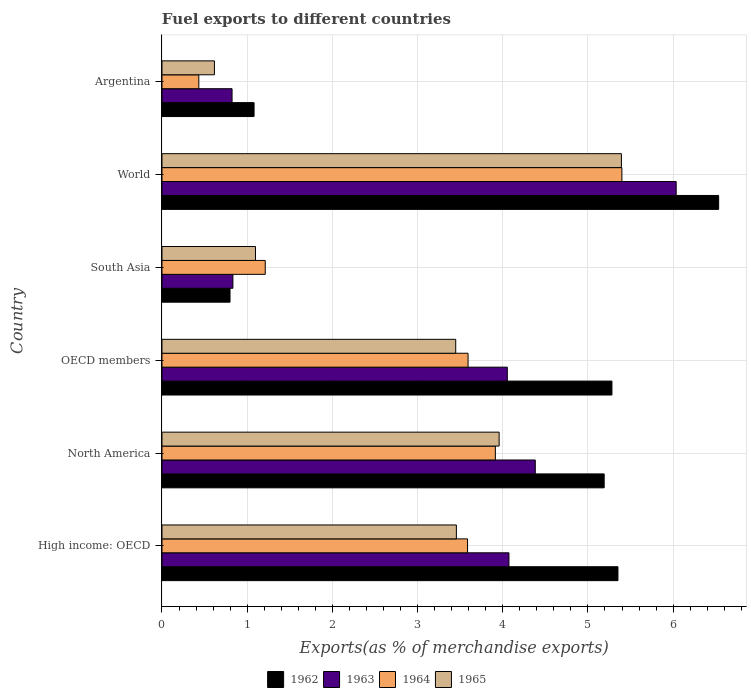How many different coloured bars are there?
Keep it short and to the point. 4. Are the number of bars on each tick of the Y-axis equal?
Ensure brevity in your answer.  Yes. In how many cases, is the number of bars for a given country not equal to the number of legend labels?
Your answer should be compact. 0. What is the percentage of exports to different countries in 1965 in Argentina?
Your answer should be very brief. 0.62. Across all countries, what is the maximum percentage of exports to different countries in 1962?
Offer a terse response. 6.53. Across all countries, what is the minimum percentage of exports to different countries in 1963?
Your answer should be compact. 0.82. In which country was the percentage of exports to different countries in 1963 minimum?
Provide a short and direct response. Argentina. What is the total percentage of exports to different countries in 1965 in the graph?
Give a very brief answer. 17.97. What is the difference between the percentage of exports to different countries in 1962 in OECD members and that in World?
Provide a succinct answer. -1.25. What is the difference between the percentage of exports to different countries in 1963 in North America and the percentage of exports to different countries in 1962 in High income: OECD?
Keep it short and to the point. -0.97. What is the average percentage of exports to different countries in 1962 per country?
Keep it short and to the point. 4.04. What is the difference between the percentage of exports to different countries in 1962 and percentage of exports to different countries in 1963 in North America?
Offer a terse response. 0.81. What is the ratio of the percentage of exports to different countries in 1964 in High income: OECD to that in North America?
Your answer should be very brief. 0.92. Is the difference between the percentage of exports to different countries in 1962 in OECD members and World greater than the difference between the percentage of exports to different countries in 1963 in OECD members and World?
Make the answer very short. Yes. What is the difference between the highest and the second highest percentage of exports to different countries in 1964?
Your answer should be very brief. 1.49. What is the difference between the highest and the lowest percentage of exports to different countries in 1965?
Your answer should be compact. 4.78. What does the 2nd bar from the top in OECD members represents?
Your response must be concise. 1964. How many bars are there?
Offer a very short reply. 24. Does the graph contain any zero values?
Provide a succinct answer. No. Does the graph contain grids?
Keep it short and to the point. Yes. Where does the legend appear in the graph?
Your response must be concise. Bottom center. How many legend labels are there?
Give a very brief answer. 4. What is the title of the graph?
Keep it short and to the point. Fuel exports to different countries. Does "2004" appear as one of the legend labels in the graph?
Provide a succinct answer. No. What is the label or title of the X-axis?
Provide a short and direct response. Exports(as % of merchandise exports). What is the label or title of the Y-axis?
Provide a succinct answer. Country. What is the Exports(as % of merchandise exports) in 1962 in High income: OECD?
Make the answer very short. 5.35. What is the Exports(as % of merchandise exports) in 1963 in High income: OECD?
Offer a terse response. 4.07. What is the Exports(as % of merchandise exports) of 1964 in High income: OECD?
Offer a very short reply. 3.59. What is the Exports(as % of merchandise exports) in 1965 in High income: OECD?
Your answer should be very brief. 3.46. What is the Exports(as % of merchandise exports) of 1962 in North America?
Keep it short and to the point. 5.19. What is the Exports(as % of merchandise exports) in 1963 in North America?
Offer a very short reply. 4.38. What is the Exports(as % of merchandise exports) in 1964 in North America?
Your answer should be compact. 3.91. What is the Exports(as % of merchandise exports) in 1965 in North America?
Offer a very short reply. 3.96. What is the Exports(as % of merchandise exports) in 1962 in OECD members?
Keep it short and to the point. 5.28. What is the Exports(as % of merchandise exports) in 1963 in OECD members?
Your answer should be very brief. 4.05. What is the Exports(as % of merchandise exports) in 1964 in OECD members?
Offer a very short reply. 3.59. What is the Exports(as % of merchandise exports) of 1965 in OECD members?
Make the answer very short. 3.45. What is the Exports(as % of merchandise exports) of 1962 in South Asia?
Make the answer very short. 0.8. What is the Exports(as % of merchandise exports) in 1963 in South Asia?
Give a very brief answer. 0.83. What is the Exports(as % of merchandise exports) in 1964 in South Asia?
Offer a very short reply. 1.21. What is the Exports(as % of merchandise exports) in 1965 in South Asia?
Ensure brevity in your answer.  1.1. What is the Exports(as % of merchandise exports) in 1962 in World?
Your response must be concise. 6.53. What is the Exports(as % of merchandise exports) of 1963 in World?
Offer a terse response. 6.04. What is the Exports(as % of merchandise exports) in 1964 in World?
Keep it short and to the point. 5.4. What is the Exports(as % of merchandise exports) in 1965 in World?
Make the answer very short. 5.39. What is the Exports(as % of merchandise exports) in 1962 in Argentina?
Keep it short and to the point. 1.08. What is the Exports(as % of merchandise exports) in 1963 in Argentina?
Your answer should be very brief. 0.82. What is the Exports(as % of merchandise exports) of 1964 in Argentina?
Your response must be concise. 0.43. What is the Exports(as % of merchandise exports) of 1965 in Argentina?
Your response must be concise. 0.62. Across all countries, what is the maximum Exports(as % of merchandise exports) in 1962?
Offer a terse response. 6.53. Across all countries, what is the maximum Exports(as % of merchandise exports) of 1963?
Provide a succinct answer. 6.04. Across all countries, what is the maximum Exports(as % of merchandise exports) in 1964?
Keep it short and to the point. 5.4. Across all countries, what is the maximum Exports(as % of merchandise exports) in 1965?
Give a very brief answer. 5.39. Across all countries, what is the minimum Exports(as % of merchandise exports) of 1962?
Ensure brevity in your answer.  0.8. Across all countries, what is the minimum Exports(as % of merchandise exports) of 1963?
Make the answer very short. 0.82. Across all countries, what is the minimum Exports(as % of merchandise exports) in 1964?
Your response must be concise. 0.43. Across all countries, what is the minimum Exports(as % of merchandise exports) of 1965?
Your response must be concise. 0.62. What is the total Exports(as % of merchandise exports) in 1962 in the graph?
Ensure brevity in your answer.  24.24. What is the total Exports(as % of merchandise exports) of 1963 in the graph?
Your response must be concise. 20.2. What is the total Exports(as % of merchandise exports) of 1964 in the graph?
Make the answer very short. 18.14. What is the total Exports(as % of merchandise exports) in 1965 in the graph?
Offer a very short reply. 17.97. What is the difference between the Exports(as % of merchandise exports) of 1962 in High income: OECD and that in North America?
Provide a short and direct response. 0.16. What is the difference between the Exports(as % of merchandise exports) in 1963 in High income: OECD and that in North America?
Offer a terse response. -0.31. What is the difference between the Exports(as % of merchandise exports) of 1964 in High income: OECD and that in North America?
Your answer should be very brief. -0.33. What is the difference between the Exports(as % of merchandise exports) of 1965 in High income: OECD and that in North America?
Your response must be concise. -0.5. What is the difference between the Exports(as % of merchandise exports) in 1962 in High income: OECD and that in OECD members?
Offer a terse response. 0.07. What is the difference between the Exports(as % of merchandise exports) of 1963 in High income: OECD and that in OECD members?
Provide a succinct answer. 0.02. What is the difference between the Exports(as % of merchandise exports) in 1964 in High income: OECD and that in OECD members?
Keep it short and to the point. -0.01. What is the difference between the Exports(as % of merchandise exports) in 1965 in High income: OECD and that in OECD members?
Make the answer very short. 0.01. What is the difference between the Exports(as % of merchandise exports) in 1962 in High income: OECD and that in South Asia?
Your answer should be compact. 4.55. What is the difference between the Exports(as % of merchandise exports) of 1963 in High income: OECD and that in South Asia?
Your response must be concise. 3.24. What is the difference between the Exports(as % of merchandise exports) in 1964 in High income: OECD and that in South Asia?
Ensure brevity in your answer.  2.37. What is the difference between the Exports(as % of merchandise exports) in 1965 in High income: OECD and that in South Asia?
Offer a terse response. 2.36. What is the difference between the Exports(as % of merchandise exports) in 1962 in High income: OECD and that in World?
Give a very brief answer. -1.18. What is the difference between the Exports(as % of merchandise exports) in 1963 in High income: OECD and that in World?
Your answer should be compact. -1.96. What is the difference between the Exports(as % of merchandise exports) of 1964 in High income: OECD and that in World?
Your response must be concise. -1.81. What is the difference between the Exports(as % of merchandise exports) in 1965 in High income: OECD and that in World?
Give a very brief answer. -1.94. What is the difference between the Exports(as % of merchandise exports) in 1962 in High income: OECD and that in Argentina?
Provide a short and direct response. 4.27. What is the difference between the Exports(as % of merchandise exports) of 1963 in High income: OECD and that in Argentina?
Make the answer very short. 3.25. What is the difference between the Exports(as % of merchandise exports) of 1964 in High income: OECD and that in Argentina?
Provide a succinct answer. 3.15. What is the difference between the Exports(as % of merchandise exports) in 1965 in High income: OECD and that in Argentina?
Give a very brief answer. 2.84. What is the difference between the Exports(as % of merchandise exports) of 1962 in North America and that in OECD members?
Make the answer very short. -0.09. What is the difference between the Exports(as % of merchandise exports) in 1963 in North America and that in OECD members?
Make the answer very short. 0.33. What is the difference between the Exports(as % of merchandise exports) of 1964 in North America and that in OECD members?
Your response must be concise. 0.32. What is the difference between the Exports(as % of merchandise exports) in 1965 in North America and that in OECD members?
Offer a terse response. 0.51. What is the difference between the Exports(as % of merchandise exports) in 1962 in North America and that in South Asia?
Make the answer very short. 4.39. What is the difference between the Exports(as % of merchandise exports) in 1963 in North America and that in South Asia?
Offer a very short reply. 3.55. What is the difference between the Exports(as % of merchandise exports) in 1964 in North America and that in South Asia?
Give a very brief answer. 2.7. What is the difference between the Exports(as % of merchandise exports) in 1965 in North America and that in South Asia?
Provide a succinct answer. 2.86. What is the difference between the Exports(as % of merchandise exports) in 1962 in North America and that in World?
Your answer should be compact. -1.34. What is the difference between the Exports(as % of merchandise exports) in 1963 in North America and that in World?
Offer a very short reply. -1.65. What is the difference between the Exports(as % of merchandise exports) of 1964 in North America and that in World?
Give a very brief answer. -1.49. What is the difference between the Exports(as % of merchandise exports) of 1965 in North America and that in World?
Give a very brief answer. -1.44. What is the difference between the Exports(as % of merchandise exports) of 1962 in North America and that in Argentina?
Offer a terse response. 4.11. What is the difference between the Exports(as % of merchandise exports) in 1963 in North America and that in Argentina?
Your answer should be very brief. 3.56. What is the difference between the Exports(as % of merchandise exports) of 1964 in North America and that in Argentina?
Offer a very short reply. 3.48. What is the difference between the Exports(as % of merchandise exports) in 1965 in North America and that in Argentina?
Give a very brief answer. 3.34. What is the difference between the Exports(as % of merchandise exports) in 1962 in OECD members and that in South Asia?
Keep it short and to the point. 4.48. What is the difference between the Exports(as % of merchandise exports) of 1963 in OECD members and that in South Asia?
Offer a terse response. 3.22. What is the difference between the Exports(as % of merchandise exports) in 1964 in OECD members and that in South Asia?
Keep it short and to the point. 2.38. What is the difference between the Exports(as % of merchandise exports) of 1965 in OECD members and that in South Asia?
Your answer should be compact. 2.35. What is the difference between the Exports(as % of merchandise exports) in 1962 in OECD members and that in World?
Offer a very short reply. -1.25. What is the difference between the Exports(as % of merchandise exports) in 1963 in OECD members and that in World?
Your answer should be very brief. -1.98. What is the difference between the Exports(as % of merchandise exports) of 1964 in OECD members and that in World?
Ensure brevity in your answer.  -1.81. What is the difference between the Exports(as % of merchandise exports) in 1965 in OECD members and that in World?
Your answer should be compact. -1.94. What is the difference between the Exports(as % of merchandise exports) in 1962 in OECD members and that in Argentina?
Provide a succinct answer. 4.2. What is the difference between the Exports(as % of merchandise exports) in 1963 in OECD members and that in Argentina?
Your answer should be very brief. 3.23. What is the difference between the Exports(as % of merchandise exports) of 1964 in OECD members and that in Argentina?
Keep it short and to the point. 3.16. What is the difference between the Exports(as % of merchandise exports) in 1965 in OECD members and that in Argentina?
Your answer should be very brief. 2.83. What is the difference between the Exports(as % of merchandise exports) of 1962 in South Asia and that in World?
Ensure brevity in your answer.  -5.74. What is the difference between the Exports(as % of merchandise exports) in 1963 in South Asia and that in World?
Offer a very short reply. -5.2. What is the difference between the Exports(as % of merchandise exports) in 1964 in South Asia and that in World?
Provide a succinct answer. -4.19. What is the difference between the Exports(as % of merchandise exports) of 1965 in South Asia and that in World?
Give a very brief answer. -4.3. What is the difference between the Exports(as % of merchandise exports) of 1962 in South Asia and that in Argentina?
Keep it short and to the point. -0.28. What is the difference between the Exports(as % of merchandise exports) in 1963 in South Asia and that in Argentina?
Provide a succinct answer. 0.01. What is the difference between the Exports(as % of merchandise exports) in 1964 in South Asia and that in Argentina?
Provide a succinct answer. 0.78. What is the difference between the Exports(as % of merchandise exports) in 1965 in South Asia and that in Argentina?
Offer a very short reply. 0.48. What is the difference between the Exports(as % of merchandise exports) of 1962 in World and that in Argentina?
Your answer should be compact. 5.45. What is the difference between the Exports(as % of merchandise exports) of 1963 in World and that in Argentina?
Your answer should be compact. 5.21. What is the difference between the Exports(as % of merchandise exports) of 1964 in World and that in Argentina?
Your answer should be very brief. 4.97. What is the difference between the Exports(as % of merchandise exports) in 1965 in World and that in Argentina?
Provide a short and direct response. 4.78. What is the difference between the Exports(as % of merchandise exports) of 1962 in High income: OECD and the Exports(as % of merchandise exports) of 1963 in North America?
Your answer should be very brief. 0.97. What is the difference between the Exports(as % of merchandise exports) of 1962 in High income: OECD and the Exports(as % of merchandise exports) of 1964 in North America?
Ensure brevity in your answer.  1.44. What is the difference between the Exports(as % of merchandise exports) in 1962 in High income: OECD and the Exports(as % of merchandise exports) in 1965 in North America?
Ensure brevity in your answer.  1.39. What is the difference between the Exports(as % of merchandise exports) in 1963 in High income: OECD and the Exports(as % of merchandise exports) in 1964 in North America?
Your answer should be compact. 0.16. What is the difference between the Exports(as % of merchandise exports) in 1963 in High income: OECD and the Exports(as % of merchandise exports) in 1965 in North America?
Give a very brief answer. 0.12. What is the difference between the Exports(as % of merchandise exports) of 1964 in High income: OECD and the Exports(as % of merchandise exports) of 1965 in North America?
Your answer should be compact. -0.37. What is the difference between the Exports(as % of merchandise exports) in 1962 in High income: OECD and the Exports(as % of merchandise exports) in 1963 in OECD members?
Offer a very short reply. 1.3. What is the difference between the Exports(as % of merchandise exports) in 1962 in High income: OECD and the Exports(as % of merchandise exports) in 1964 in OECD members?
Your response must be concise. 1.76. What is the difference between the Exports(as % of merchandise exports) of 1962 in High income: OECD and the Exports(as % of merchandise exports) of 1965 in OECD members?
Keep it short and to the point. 1.9. What is the difference between the Exports(as % of merchandise exports) of 1963 in High income: OECD and the Exports(as % of merchandise exports) of 1964 in OECD members?
Provide a short and direct response. 0.48. What is the difference between the Exports(as % of merchandise exports) of 1963 in High income: OECD and the Exports(as % of merchandise exports) of 1965 in OECD members?
Offer a very short reply. 0.62. What is the difference between the Exports(as % of merchandise exports) in 1964 in High income: OECD and the Exports(as % of merchandise exports) in 1965 in OECD members?
Offer a terse response. 0.14. What is the difference between the Exports(as % of merchandise exports) of 1962 in High income: OECD and the Exports(as % of merchandise exports) of 1963 in South Asia?
Your response must be concise. 4.52. What is the difference between the Exports(as % of merchandise exports) of 1962 in High income: OECD and the Exports(as % of merchandise exports) of 1964 in South Asia?
Provide a short and direct response. 4.14. What is the difference between the Exports(as % of merchandise exports) of 1962 in High income: OECD and the Exports(as % of merchandise exports) of 1965 in South Asia?
Keep it short and to the point. 4.25. What is the difference between the Exports(as % of merchandise exports) of 1963 in High income: OECD and the Exports(as % of merchandise exports) of 1964 in South Asia?
Provide a short and direct response. 2.86. What is the difference between the Exports(as % of merchandise exports) in 1963 in High income: OECD and the Exports(as % of merchandise exports) in 1965 in South Asia?
Keep it short and to the point. 2.98. What is the difference between the Exports(as % of merchandise exports) in 1964 in High income: OECD and the Exports(as % of merchandise exports) in 1965 in South Asia?
Provide a succinct answer. 2.49. What is the difference between the Exports(as % of merchandise exports) of 1962 in High income: OECD and the Exports(as % of merchandise exports) of 1963 in World?
Ensure brevity in your answer.  -0.68. What is the difference between the Exports(as % of merchandise exports) of 1962 in High income: OECD and the Exports(as % of merchandise exports) of 1964 in World?
Make the answer very short. -0.05. What is the difference between the Exports(as % of merchandise exports) of 1962 in High income: OECD and the Exports(as % of merchandise exports) of 1965 in World?
Offer a terse response. -0.04. What is the difference between the Exports(as % of merchandise exports) of 1963 in High income: OECD and the Exports(as % of merchandise exports) of 1964 in World?
Make the answer very short. -1.33. What is the difference between the Exports(as % of merchandise exports) in 1963 in High income: OECD and the Exports(as % of merchandise exports) in 1965 in World?
Keep it short and to the point. -1.32. What is the difference between the Exports(as % of merchandise exports) in 1964 in High income: OECD and the Exports(as % of merchandise exports) in 1965 in World?
Ensure brevity in your answer.  -1.81. What is the difference between the Exports(as % of merchandise exports) in 1962 in High income: OECD and the Exports(as % of merchandise exports) in 1963 in Argentina?
Ensure brevity in your answer.  4.53. What is the difference between the Exports(as % of merchandise exports) in 1962 in High income: OECD and the Exports(as % of merchandise exports) in 1964 in Argentina?
Offer a very short reply. 4.92. What is the difference between the Exports(as % of merchandise exports) in 1962 in High income: OECD and the Exports(as % of merchandise exports) in 1965 in Argentina?
Your answer should be compact. 4.74. What is the difference between the Exports(as % of merchandise exports) in 1963 in High income: OECD and the Exports(as % of merchandise exports) in 1964 in Argentina?
Provide a short and direct response. 3.64. What is the difference between the Exports(as % of merchandise exports) of 1963 in High income: OECD and the Exports(as % of merchandise exports) of 1965 in Argentina?
Keep it short and to the point. 3.46. What is the difference between the Exports(as % of merchandise exports) of 1964 in High income: OECD and the Exports(as % of merchandise exports) of 1965 in Argentina?
Ensure brevity in your answer.  2.97. What is the difference between the Exports(as % of merchandise exports) in 1962 in North America and the Exports(as % of merchandise exports) in 1963 in OECD members?
Your answer should be very brief. 1.14. What is the difference between the Exports(as % of merchandise exports) of 1962 in North America and the Exports(as % of merchandise exports) of 1964 in OECD members?
Give a very brief answer. 1.6. What is the difference between the Exports(as % of merchandise exports) of 1962 in North America and the Exports(as % of merchandise exports) of 1965 in OECD members?
Your answer should be compact. 1.74. What is the difference between the Exports(as % of merchandise exports) of 1963 in North America and the Exports(as % of merchandise exports) of 1964 in OECD members?
Your answer should be compact. 0.79. What is the difference between the Exports(as % of merchandise exports) of 1963 in North America and the Exports(as % of merchandise exports) of 1965 in OECD members?
Provide a succinct answer. 0.93. What is the difference between the Exports(as % of merchandise exports) in 1964 in North America and the Exports(as % of merchandise exports) in 1965 in OECD members?
Your answer should be very brief. 0.47. What is the difference between the Exports(as % of merchandise exports) of 1962 in North America and the Exports(as % of merchandise exports) of 1963 in South Asia?
Offer a terse response. 4.36. What is the difference between the Exports(as % of merchandise exports) of 1962 in North America and the Exports(as % of merchandise exports) of 1964 in South Asia?
Provide a succinct answer. 3.98. What is the difference between the Exports(as % of merchandise exports) in 1962 in North America and the Exports(as % of merchandise exports) in 1965 in South Asia?
Make the answer very short. 4.09. What is the difference between the Exports(as % of merchandise exports) in 1963 in North America and the Exports(as % of merchandise exports) in 1964 in South Asia?
Your response must be concise. 3.17. What is the difference between the Exports(as % of merchandise exports) in 1963 in North America and the Exports(as % of merchandise exports) in 1965 in South Asia?
Ensure brevity in your answer.  3.28. What is the difference between the Exports(as % of merchandise exports) of 1964 in North America and the Exports(as % of merchandise exports) of 1965 in South Asia?
Make the answer very short. 2.82. What is the difference between the Exports(as % of merchandise exports) in 1962 in North America and the Exports(as % of merchandise exports) in 1963 in World?
Your answer should be compact. -0.85. What is the difference between the Exports(as % of merchandise exports) of 1962 in North America and the Exports(as % of merchandise exports) of 1964 in World?
Ensure brevity in your answer.  -0.21. What is the difference between the Exports(as % of merchandise exports) of 1962 in North America and the Exports(as % of merchandise exports) of 1965 in World?
Offer a terse response. -0.2. What is the difference between the Exports(as % of merchandise exports) of 1963 in North America and the Exports(as % of merchandise exports) of 1964 in World?
Provide a short and direct response. -1.02. What is the difference between the Exports(as % of merchandise exports) of 1963 in North America and the Exports(as % of merchandise exports) of 1965 in World?
Your answer should be compact. -1.01. What is the difference between the Exports(as % of merchandise exports) of 1964 in North America and the Exports(as % of merchandise exports) of 1965 in World?
Make the answer very short. -1.48. What is the difference between the Exports(as % of merchandise exports) in 1962 in North America and the Exports(as % of merchandise exports) in 1963 in Argentina?
Offer a very short reply. 4.37. What is the difference between the Exports(as % of merchandise exports) of 1962 in North America and the Exports(as % of merchandise exports) of 1964 in Argentina?
Offer a very short reply. 4.76. What is the difference between the Exports(as % of merchandise exports) of 1962 in North America and the Exports(as % of merchandise exports) of 1965 in Argentina?
Your answer should be very brief. 4.58. What is the difference between the Exports(as % of merchandise exports) in 1963 in North America and the Exports(as % of merchandise exports) in 1964 in Argentina?
Offer a terse response. 3.95. What is the difference between the Exports(as % of merchandise exports) of 1963 in North America and the Exports(as % of merchandise exports) of 1965 in Argentina?
Offer a terse response. 3.77. What is the difference between the Exports(as % of merchandise exports) in 1964 in North America and the Exports(as % of merchandise exports) in 1965 in Argentina?
Offer a terse response. 3.3. What is the difference between the Exports(as % of merchandise exports) of 1962 in OECD members and the Exports(as % of merchandise exports) of 1963 in South Asia?
Provide a succinct answer. 4.45. What is the difference between the Exports(as % of merchandise exports) of 1962 in OECD members and the Exports(as % of merchandise exports) of 1964 in South Asia?
Your response must be concise. 4.07. What is the difference between the Exports(as % of merchandise exports) in 1962 in OECD members and the Exports(as % of merchandise exports) in 1965 in South Asia?
Provide a short and direct response. 4.18. What is the difference between the Exports(as % of merchandise exports) in 1963 in OECD members and the Exports(as % of merchandise exports) in 1964 in South Asia?
Provide a succinct answer. 2.84. What is the difference between the Exports(as % of merchandise exports) of 1963 in OECD members and the Exports(as % of merchandise exports) of 1965 in South Asia?
Your answer should be very brief. 2.96. What is the difference between the Exports(as % of merchandise exports) of 1964 in OECD members and the Exports(as % of merchandise exports) of 1965 in South Asia?
Your answer should be compact. 2.5. What is the difference between the Exports(as % of merchandise exports) of 1962 in OECD members and the Exports(as % of merchandise exports) of 1963 in World?
Offer a terse response. -0.75. What is the difference between the Exports(as % of merchandise exports) in 1962 in OECD members and the Exports(as % of merchandise exports) in 1964 in World?
Make the answer very short. -0.12. What is the difference between the Exports(as % of merchandise exports) of 1962 in OECD members and the Exports(as % of merchandise exports) of 1965 in World?
Ensure brevity in your answer.  -0.11. What is the difference between the Exports(as % of merchandise exports) of 1963 in OECD members and the Exports(as % of merchandise exports) of 1964 in World?
Your answer should be very brief. -1.35. What is the difference between the Exports(as % of merchandise exports) of 1963 in OECD members and the Exports(as % of merchandise exports) of 1965 in World?
Your response must be concise. -1.34. What is the difference between the Exports(as % of merchandise exports) of 1964 in OECD members and the Exports(as % of merchandise exports) of 1965 in World?
Give a very brief answer. -1.8. What is the difference between the Exports(as % of merchandise exports) of 1962 in OECD members and the Exports(as % of merchandise exports) of 1963 in Argentina?
Provide a short and direct response. 4.46. What is the difference between the Exports(as % of merchandise exports) of 1962 in OECD members and the Exports(as % of merchandise exports) of 1964 in Argentina?
Give a very brief answer. 4.85. What is the difference between the Exports(as % of merchandise exports) of 1962 in OECD members and the Exports(as % of merchandise exports) of 1965 in Argentina?
Offer a terse response. 4.67. What is the difference between the Exports(as % of merchandise exports) in 1963 in OECD members and the Exports(as % of merchandise exports) in 1964 in Argentina?
Make the answer very short. 3.62. What is the difference between the Exports(as % of merchandise exports) of 1963 in OECD members and the Exports(as % of merchandise exports) of 1965 in Argentina?
Provide a succinct answer. 3.44. What is the difference between the Exports(as % of merchandise exports) of 1964 in OECD members and the Exports(as % of merchandise exports) of 1965 in Argentina?
Offer a terse response. 2.98. What is the difference between the Exports(as % of merchandise exports) in 1962 in South Asia and the Exports(as % of merchandise exports) in 1963 in World?
Your answer should be compact. -5.24. What is the difference between the Exports(as % of merchandise exports) in 1962 in South Asia and the Exports(as % of merchandise exports) in 1964 in World?
Provide a succinct answer. -4.6. What is the difference between the Exports(as % of merchandise exports) of 1962 in South Asia and the Exports(as % of merchandise exports) of 1965 in World?
Provide a succinct answer. -4.59. What is the difference between the Exports(as % of merchandise exports) in 1963 in South Asia and the Exports(as % of merchandise exports) in 1964 in World?
Ensure brevity in your answer.  -4.57. What is the difference between the Exports(as % of merchandise exports) of 1963 in South Asia and the Exports(as % of merchandise exports) of 1965 in World?
Offer a very short reply. -4.56. What is the difference between the Exports(as % of merchandise exports) in 1964 in South Asia and the Exports(as % of merchandise exports) in 1965 in World?
Your response must be concise. -4.18. What is the difference between the Exports(as % of merchandise exports) in 1962 in South Asia and the Exports(as % of merchandise exports) in 1963 in Argentina?
Offer a terse response. -0.02. What is the difference between the Exports(as % of merchandise exports) of 1962 in South Asia and the Exports(as % of merchandise exports) of 1964 in Argentina?
Ensure brevity in your answer.  0.37. What is the difference between the Exports(as % of merchandise exports) in 1962 in South Asia and the Exports(as % of merchandise exports) in 1965 in Argentina?
Ensure brevity in your answer.  0.18. What is the difference between the Exports(as % of merchandise exports) in 1963 in South Asia and the Exports(as % of merchandise exports) in 1964 in Argentina?
Keep it short and to the point. 0.4. What is the difference between the Exports(as % of merchandise exports) of 1963 in South Asia and the Exports(as % of merchandise exports) of 1965 in Argentina?
Ensure brevity in your answer.  0.22. What is the difference between the Exports(as % of merchandise exports) of 1964 in South Asia and the Exports(as % of merchandise exports) of 1965 in Argentina?
Offer a very short reply. 0.6. What is the difference between the Exports(as % of merchandise exports) in 1962 in World and the Exports(as % of merchandise exports) in 1963 in Argentina?
Provide a succinct answer. 5.71. What is the difference between the Exports(as % of merchandise exports) of 1962 in World and the Exports(as % of merchandise exports) of 1964 in Argentina?
Your response must be concise. 6.1. What is the difference between the Exports(as % of merchandise exports) of 1962 in World and the Exports(as % of merchandise exports) of 1965 in Argentina?
Your answer should be very brief. 5.92. What is the difference between the Exports(as % of merchandise exports) of 1963 in World and the Exports(as % of merchandise exports) of 1964 in Argentina?
Give a very brief answer. 5.6. What is the difference between the Exports(as % of merchandise exports) in 1963 in World and the Exports(as % of merchandise exports) in 1965 in Argentina?
Offer a terse response. 5.42. What is the difference between the Exports(as % of merchandise exports) in 1964 in World and the Exports(as % of merchandise exports) in 1965 in Argentina?
Make the answer very short. 4.78. What is the average Exports(as % of merchandise exports) of 1962 per country?
Make the answer very short. 4.04. What is the average Exports(as % of merchandise exports) of 1963 per country?
Keep it short and to the point. 3.37. What is the average Exports(as % of merchandise exports) in 1964 per country?
Your answer should be compact. 3.02. What is the average Exports(as % of merchandise exports) of 1965 per country?
Your answer should be compact. 2.99. What is the difference between the Exports(as % of merchandise exports) of 1962 and Exports(as % of merchandise exports) of 1963 in High income: OECD?
Keep it short and to the point. 1.28. What is the difference between the Exports(as % of merchandise exports) of 1962 and Exports(as % of merchandise exports) of 1964 in High income: OECD?
Keep it short and to the point. 1.77. What is the difference between the Exports(as % of merchandise exports) of 1962 and Exports(as % of merchandise exports) of 1965 in High income: OECD?
Give a very brief answer. 1.9. What is the difference between the Exports(as % of merchandise exports) of 1963 and Exports(as % of merchandise exports) of 1964 in High income: OECD?
Provide a succinct answer. 0.49. What is the difference between the Exports(as % of merchandise exports) of 1963 and Exports(as % of merchandise exports) of 1965 in High income: OECD?
Provide a succinct answer. 0.62. What is the difference between the Exports(as % of merchandise exports) of 1964 and Exports(as % of merchandise exports) of 1965 in High income: OECD?
Provide a short and direct response. 0.13. What is the difference between the Exports(as % of merchandise exports) of 1962 and Exports(as % of merchandise exports) of 1963 in North America?
Your answer should be compact. 0.81. What is the difference between the Exports(as % of merchandise exports) in 1962 and Exports(as % of merchandise exports) in 1964 in North America?
Your response must be concise. 1.28. What is the difference between the Exports(as % of merchandise exports) in 1962 and Exports(as % of merchandise exports) in 1965 in North America?
Give a very brief answer. 1.23. What is the difference between the Exports(as % of merchandise exports) of 1963 and Exports(as % of merchandise exports) of 1964 in North America?
Your response must be concise. 0.47. What is the difference between the Exports(as % of merchandise exports) in 1963 and Exports(as % of merchandise exports) in 1965 in North America?
Your answer should be very brief. 0.42. What is the difference between the Exports(as % of merchandise exports) of 1964 and Exports(as % of merchandise exports) of 1965 in North America?
Provide a succinct answer. -0.04. What is the difference between the Exports(as % of merchandise exports) in 1962 and Exports(as % of merchandise exports) in 1963 in OECD members?
Your answer should be very brief. 1.23. What is the difference between the Exports(as % of merchandise exports) of 1962 and Exports(as % of merchandise exports) of 1964 in OECD members?
Keep it short and to the point. 1.69. What is the difference between the Exports(as % of merchandise exports) in 1962 and Exports(as % of merchandise exports) in 1965 in OECD members?
Provide a succinct answer. 1.83. What is the difference between the Exports(as % of merchandise exports) of 1963 and Exports(as % of merchandise exports) of 1964 in OECD members?
Offer a terse response. 0.46. What is the difference between the Exports(as % of merchandise exports) in 1963 and Exports(as % of merchandise exports) in 1965 in OECD members?
Your answer should be compact. 0.61. What is the difference between the Exports(as % of merchandise exports) in 1964 and Exports(as % of merchandise exports) in 1965 in OECD members?
Ensure brevity in your answer.  0.14. What is the difference between the Exports(as % of merchandise exports) in 1962 and Exports(as % of merchandise exports) in 1963 in South Asia?
Make the answer very short. -0.03. What is the difference between the Exports(as % of merchandise exports) of 1962 and Exports(as % of merchandise exports) of 1964 in South Asia?
Make the answer very short. -0.41. What is the difference between the Exports(as % of merchandise exports) of 1962 and Exports(as % of merchandise exports) of 1965 in South Asia?
Make the answer very short. -0.3. What is the difference between the Exports(as % of merchandise exports) in 1963 and Exports(as % of merchandise exports) in 1964 in South Asia?
Your answer should be very brief. -0.38. What is the difference between the Exports(as % of merchandise exports) of 1963 and Exports(as % of merchandise exports) of 1965 in South Asia?
Provide a succinct answer. -0.27. What is the difference between the Exports(as % of merchandise exports) of 1964 and Exports(as % of merchandise exports) of 1965 in South Asia?
Your answer should be compact. 0.11. What is the difference between the Exports(as % of merchandise exports) in 1962 and Exports(as % of merchandise exports) in 1963 in World?
Offer a terse response. 0.5. What is the difference between the Exports(as % of merchandise exports) of 1962 and Exports(as % of merchandise exports) of 1964 in World?
Your response must be concise. 1.14. What is the difference between the Exports(as % of merchandise exports) of 1962 and Exports(as % of merchandise exports) of 1965 in World?
Make the answer very short. 1.14. What is the difference between the Exports(as % of merchandise exports) of 1963 and Exports(as % of merchandise exports) of 1964 in World?
Your response must be concise. 0.64. What is the difference between the Exports(as % of merchandise exports) in 1963 and Exports(as % of merchandise exports) in 1965 in World?
Offer a very short reply. 0.64. What is the difference between the Exports(as % of merchandise exports) in 1964 and Exports(as % of merchandise exports) in 1965 in World?
Offer a very short reply. 0.01. What is the difference between the Exports(as % of merchandise exports) in 1962 and Exports(as % of merchandise exports) in 1963 in Argentina?
Provide a succinct answer. 0.26. What is the difference between the Exports(as % of merchandise exports) of 1962 and Exports(as % of merchandise exports) of 1964 in Argentina?
Offer a very short reply. 0.65. What is the difference between the Exports(as % of merchandise exports) of 1962 and Exports(as % of merchandise exports) of 1965 in Argentina?
Your answer should be very brief. 0.47. What is the difference between the Exports(as % of merchandise exports) of 1963 and Exports(as % of merchandise exports) of 1964 in Argentina?
Offer a very short reply. 0.39. What is the difference between the Exports(as % of merchandise exports) of 1963 and Exports(as % of merchandise exports) of 1965 in Argentina?
Offer a terse response. 0.21. What is the difference between the Exports(as % of merchandise exports) of 1964 and Exports(as % of merchandise exports) of 1965 in Argentina?
Your response must be concise. -0.18. What is the ratio of the Exports(as % of merchandise exports) in 1962 in High income: OECD to that in North America?
Offer a terse response. 1.03. What is the ratio of the Exports(as % of merchandise exports) of 1963 in High income: OECD to that in North America?
Ensure brevity in your answer.  0.93. What is the ratio of the Exports(as % of merchandise exports) of 1964 in High income: OECD to that in North America?
Keep it short and to the point. 0.92. What is the ratio of the Exports(as % of merchandise exports) in 1965 in High income: OECD to that in North America?
Give a very brief answer. 0.87. What is the ratio of the Exports(as % of merchandise exports) of 1962 in High income: OECD to that in OECD members?
Your answer should be compact. 1.01. What is the ratio of the Exports(as % of merchandise exports) in 1964 in High income: OECD to that in OECD members?
Offer a terse response. 1. What is the ratio of the Exports(as % of merchandise exports) of 1962 in High income: OECD to that in South Asia?
Make the answer very short. 6.7. What is the ratio of the Exports(as % of merchandise exports) of 1963 in High income: OECD to that in South Asia?
Ensure brevity in your answer.  4.89. What is the ratio of the Exports(as % of merchandise exports) of 1964 in High income: OECD to that in South Asia?
Make the answer very short. 2.96. What is the ratio of the Exports(as % of merchandise exports) in 1965 in High income: OECD to that in South Asia?
Ensure brevity in your answer.  3.15. What is the ratio of the Exports(as % of merchandise exports) in 1962 in High income: OECD to that in World?
Provide a short and direct response. 0.82. What is the ratio of the Exports(as % of merchandise exports) of 1963 in High income: OECD to that in World?
Give a very brief answer. 0.67. What is the ratio of the Exports(as % of merchandise exports) of 1964 in High income: OECD to that in World?
Keep it short and to the point. 0.66. What is the ratio of the Exports(as % of merchandise exports) of 1965 in High income: OECD to that in World?
Your answer should be very brief. 0.64. What is the ratio of the Exports(as % of merchandise exports) in 1962 in High income: OECD to that in Argentina?
Ensure brevity in your answer.  4.95. What is the ratio of the Exports(as % of merchandise exports) of 1963 in High income: OECD to that in Argentina?
Give a very brief answer. 4.95. What is the ratio of the Exports(as % of merchandise exports) of 1964 in High income: OECD to that in Argentina?
Provide a short and direct response. 8.3. What is the ratio of the Exports(as % of merchandise exports) of 1965 in High income: OECD to that in Argentina?
Offer a terse response. 5.61. What is the ratio of the Exports(as % of merchandise exports) in 1962 in North America to that in OECD members?
Your response must be concise. 0.98. What is the ratio of the Exports(as % of merchandise exports) in 1963 in North America to that in OECD members?
Give a very brief answer. 1.08. What is the ratio of the Exports(as % of merchandise exports) of 1964 in North America to that in OECD members?
Provide a succinct answer. 1.09. What is the ratio of the Exports(as % of merchandise exports) in 1965 in North America to that in OECD members?
Your answer should be very brief. 1.15. What is the ratio of the Exports(as % of merchandise exports) of 1962 in North America to that in South Asia?
Provide a succinct answer. 6.5. What is the ratio of the Exports(as % of merchandise exports) of 1963 in North America to that in South Asia?
Make the answer very short. 5.26. What is the ratio of the Exports(as % of merchandise exports) of 1964 in North America to that in South Asia?
Make the answer very short. 3.23. What is the ratio of the Exports(as % of merchandise exports) in 1965 in North America to that in South Asia?
Keep it short and to the point. 3.61. What is the ratio of the Exports(as % of merchandise exports) of 1962 in North America to that in World?
Your response must be concise. 0.79. What is the ratio of the Exports(as % of merchandise exports) of 1963 in North America to that in World?
Provide a succinct answer. 0.73. What is the ratio of the Exports(as % of merchandise exports) of 1964 in North America to that in World?
Your response must be concise. 0.72. What is the ratio of the Exports(as % of merchandise exports) in 1965 in North America to that in World?
Offer a very short reply. 0.73. What is the ratio of the Exports(as % of merchandise exports) of 1962 in North America to that in Argentina?
Provide a succinct answer. 4.8. What is the ratio of the Exports(as % of merchandise exports) of 1963 in North America to that in Argentina?
Ensure brevity in your answer.  5.33. What is the ratio of the Exports(as % of merchandise exports) in 1964 in North America to that in Argentina?
Keep it short and to the point. 9.05. What is the ratio of the Exports(as % of merchandise exports) of 1965 in North America to that in Argentina?
Offer a very short reply. 6.43. What is the ratio of the Exports(as % of merchandise exports) in 1962 in OECD members to that in South Asia?
Keep it short and to the point. 6.61. What is the ratio of the Exports(as % of merchandise exports) of 1963 in OECD members to that in South Asia?
Keep it short and to the point. 4.87. What is the ratio of the Exports(as % of merchandise exports) of 1964 in OECD members to that in South Asia?
Give a very brief answer. 2.96. What is the ratio of the Exports(as % of merchandise exports) of 1965 in OECD members to that in South Asia?
Offer a terse response. 3.14. What is the ratio of the Exports(as % of merchandise exports) of 1962 in OECD members to that in World?
Offer a terse response. 0.81. What is the ratio of the Exports(as % of merchandise exports) in 1963 in OECD members to that in World?
Provide a short and direct response. 0.67. What is the ratio of the Exports(as % of merchandise exports) of 1964 in OECD members to that in World?
Offer a terse response. 0.67. What is the ratio of the Exports(as % of merchandise exports) of 1965 in OECD members to that in World?
Your answer should be very brief. 0.64. What is the ratio of the Exports(as % of merchandise exports) in 1962 in OECD members to that in Argentina?
Your answer should be compact. 4.89. What is the ratio of the Exports(as % of merchandise exports) of 1963 in OECD members to that in Argentina?
Provide a short and direct response. 4.93. What is the ratio of the Exports(as % of merchandise exports) in 1964 in OECD members to that in Argentina?
Make the answer very short. 8.31. What is the ratio of the Exports(as % of merchandise exports) of 1965 in OECD members to that in Argentina?
Your response must be concise. 5.6. What is the ratio of the Exports(as % of merchandise exports) in 1962 in South Asia to that in World?
Ensure brevity in your answer.  0.12. What is the ratio of the Exports(as % of merchandise exports) of 1963 in South Asia to that in World?
Provide a succinct answer. 0.14. What is the ratio of the Exports(as % of merchandise exports) of 1964 in South Asia to that in World?
Provide a succinct answer. 0.22. What is the ratio of the Exports(as % of merchandise exports) of 1965 in South Asia to that in World?
Offer a terse response. 0.2. What is the ratio of the Exports(as % of merchandise exports) in 1962 in South Asia to that in Argentina?
Your response must be concise. 0.74. What is the ratio of the Exports(as % of merchandise exports) of 1963 in South Asia to that in Argentina?
Ensure brevity in your answer.  1.01. What is the ratio of the Exports(as % of merchandise exports) of 1964 in South Asia to that in Argentina?
Your answer should be compact. 2.8. What is the ratio of the Exports(as % of merchandise exports) in 1965 in South Asia to that in Argentina?
Provide a short and direct response. 1.78. What is the ratio of the Exports(as % of merchandise exports) of 1962 in World to that in Argentina?
Offer a terse response. 6.05. What is the ratio of the Exports(as % of merchandise exports) of 1963 in World to that in Argentina?
Provide a succinct answer. 7.34. What is the ratio of the Exports(as % of merchandise exports) in 1964 in World to that in Argentina?
Give a very brief answer. 12.49. What is the ratio of the Exports(as % of merchandise exports) of 1965 in World to that in Argentina?
Ensure brevity in your answer.  8.76. What is the difference between the highest and the second highest Exports(as % of merchandise exports) in 1962?
Keep it short and to the point. 1.18. What is the difference between the highest and the second highest Exports(as % of merchandise exports) of 1963?
Give a very brief answer. 1.65. What is the difference between the highest and the second highest Exports(as % of merchandise exports) of 1964?
Your response must be concise. 1.49. What is the difference between the highest and the second highest Exports(as % of merchandise exports) of 1965?
Provide a succinct answer. 1.44. What is the difference between the highest and the lowest Exports(as % of merchandise exports) in 1962?
Offer a very short reply. 5.74. What is the difference between the highest and the lowest Exports(as % of merchandise exports) in 1963?
Offer a very short reply. 5.21. What is the difference between the highest and the lowest Exports(as % of merchandise exports) in 1964?
Offer a very short reply. 4.97. What is the difference between the highest and the lowest Exports(as % of merchandise exports) in 1965?
Your answer should be very brief. 4.78. 